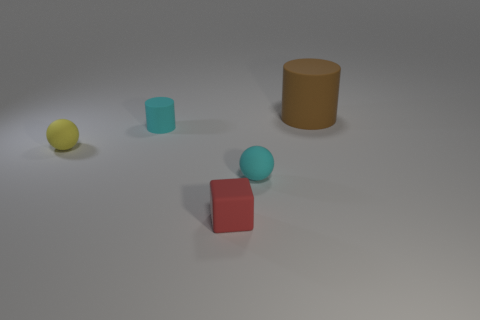Add 4 green blocks. How many objects exist? 9 Subtract all blocks. How many objects are left? 4 Subtract all large cyan rubber balls. Subtract all brown matte things. How many objects are left? 4 Add 1 matte balls. How many matte balls are left? 3 Add 5 matte blocks. How many matte blocks exist? 6 Subtract 0 red cylinders. How many objects are left? 5 